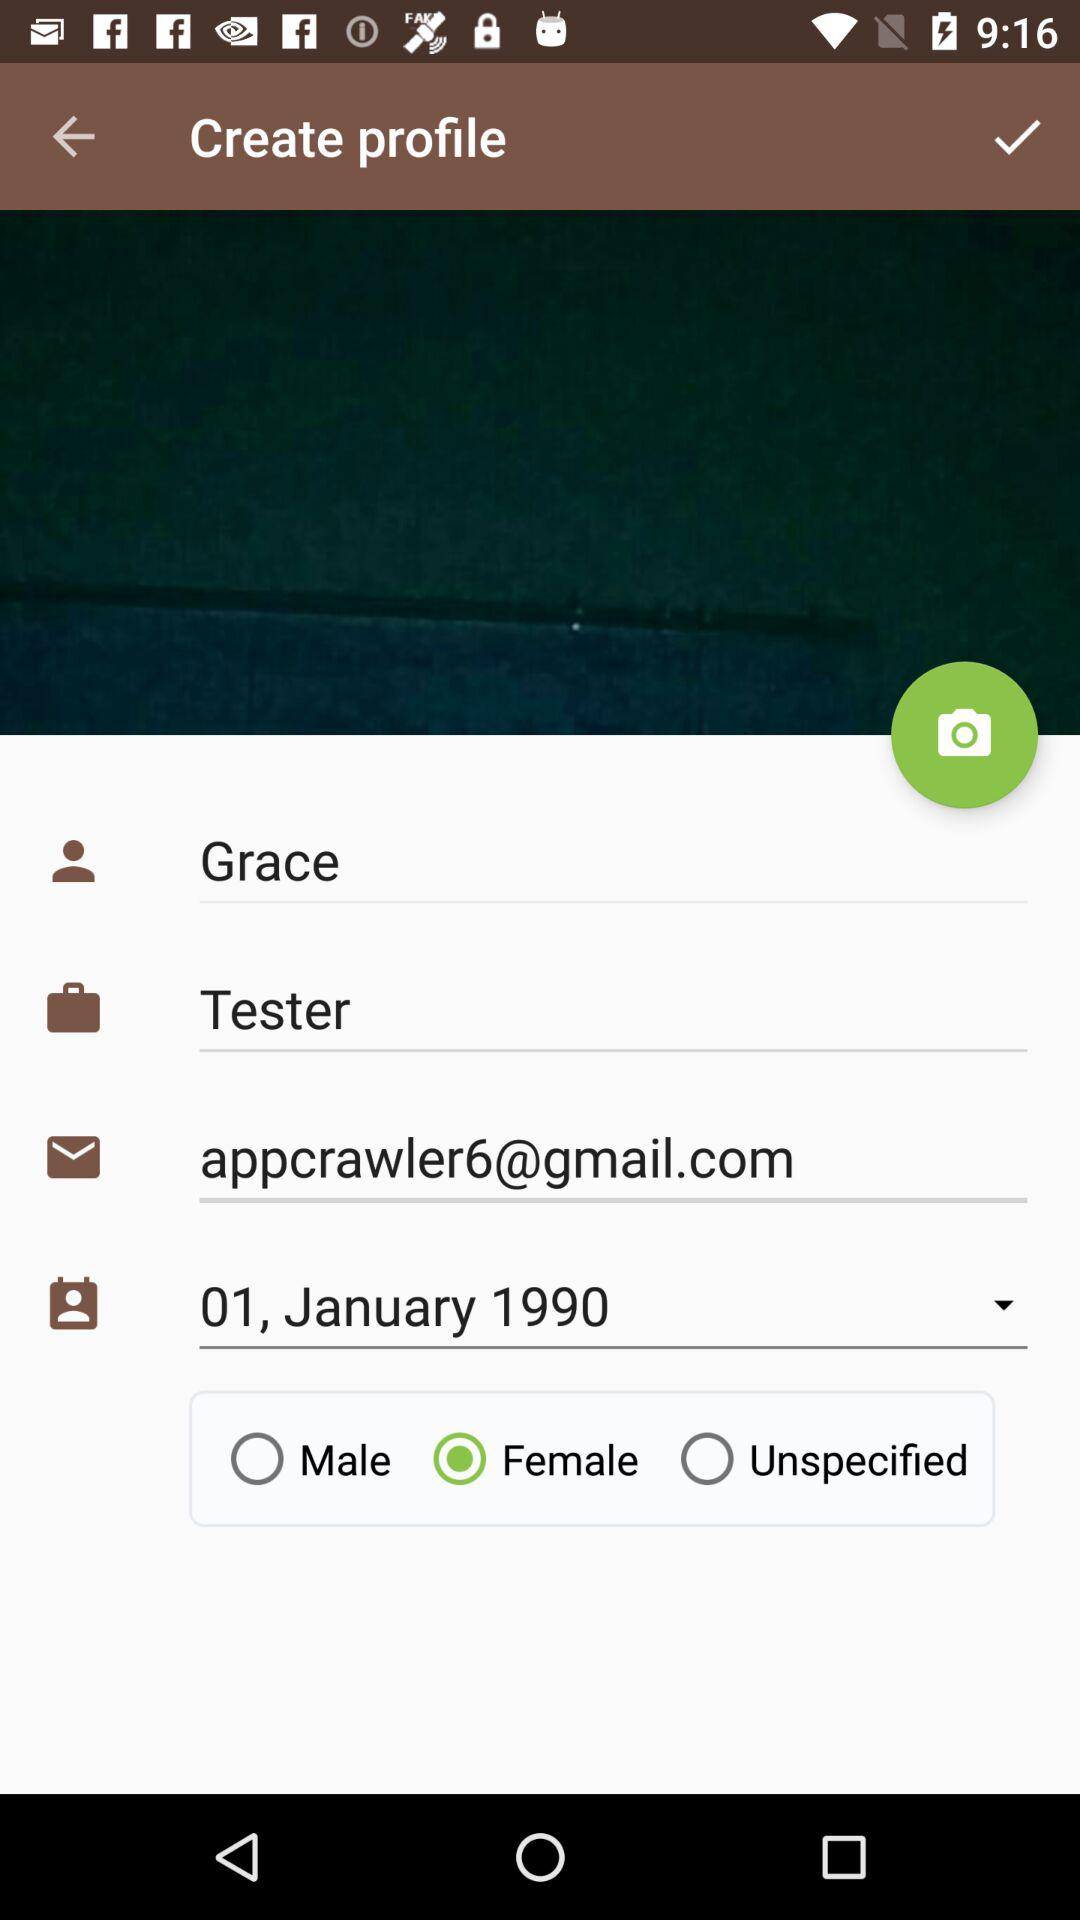What is the email address? The email address is appcrawler6@gmail.com. 